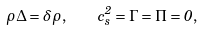<formula> <loc_0><loc_0><loc_500><loc_500>\rho \Delta = \delta \rho , \quad c _ { s } ^ { 2 } = \Gamma = \Pi = 0 ,</formula> 